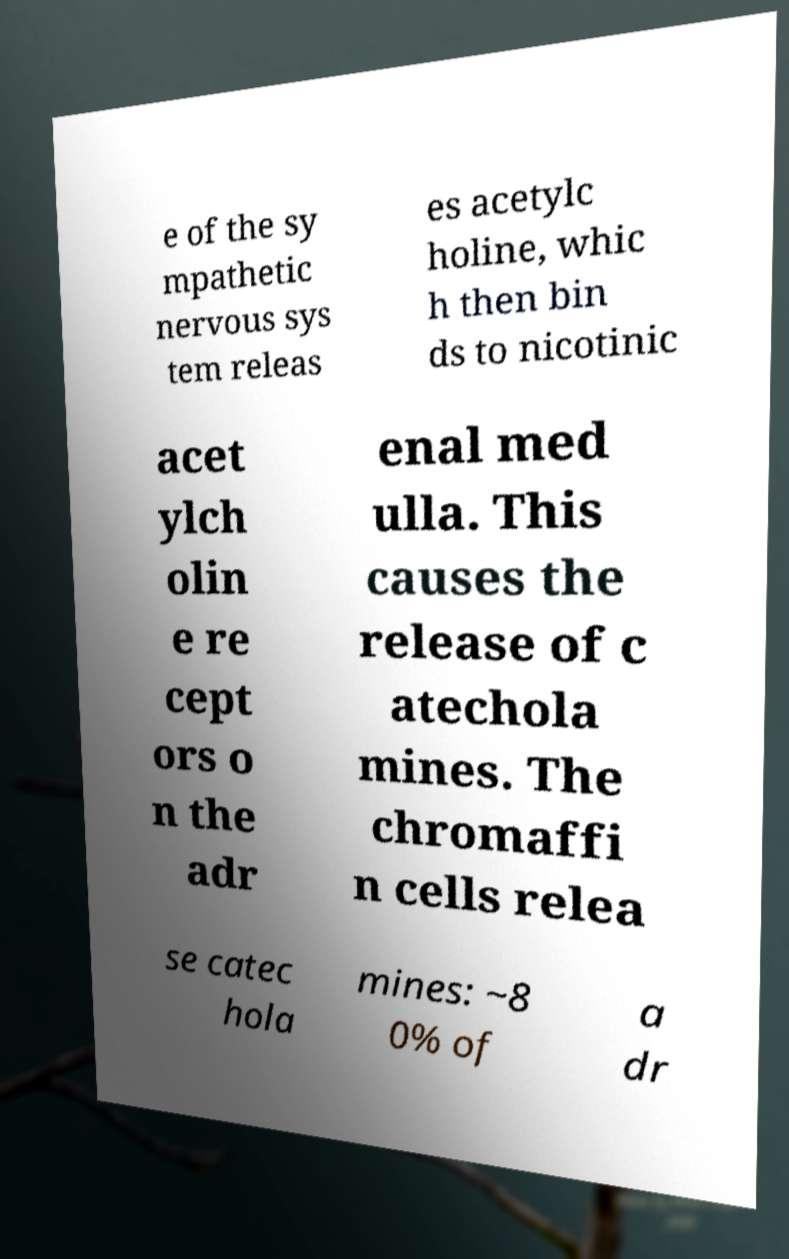I need the written content from this picture converted into text. Can you do that? e of the sy mpathetic nervous sys tem releas es acetylc holine, whic h then bin ds to nicotinic acet ylch olin e re cept ors o n the adr enal med ulla. This causes the release of c atechola mines. The chromaffi n cells relea se catec hola mines: ~8 0% of a dr 